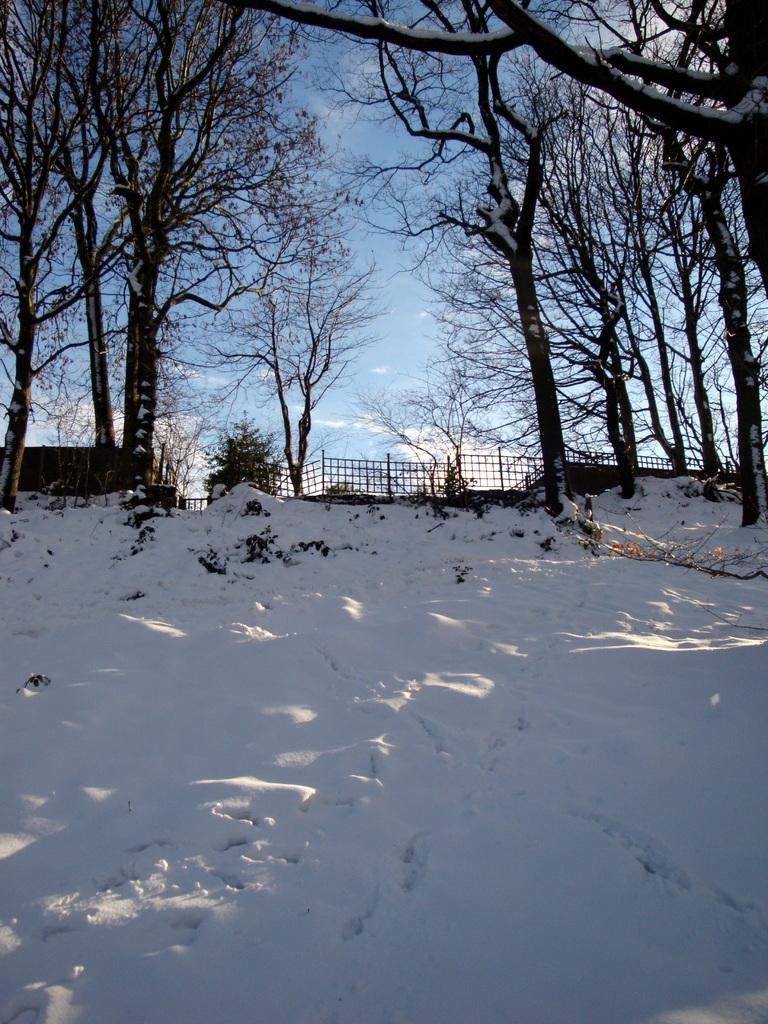What is the main feature of the image? The center of the image contains the sky. What can be seen in the sky? Clouds are visible in the sky. What type of vegetation is present in the image? Trees are present in the image. What architectural elements can be seen in the image? Fences are in the image. What weather condition is depicted in the image? Snow is visible in the image. How many stars are arranged in the sky in the image? There are no stars visible in the image; only clouds are present in the sky. What type of straw is used to decorate the trees in the image? There is no straw present in the image; it features trees, fences, and snow. 